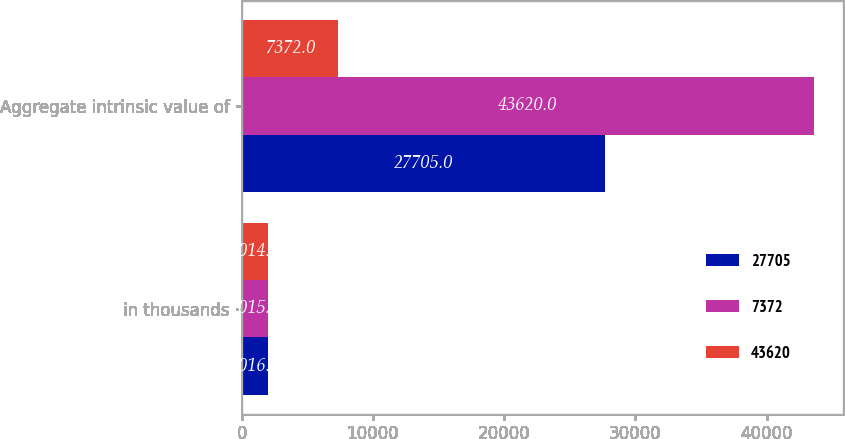Convert chart. <chart><loc_0><loc_0><loc_500><loc_500><stacked_bar_chart><ecel><fcel>in thousands<fcel>Aggregate intrinsic value of<nl><fcel>27705<fcel>2016<fcel>27705<nl><fcel>7372<fcel>2015<fcel>43620<nl><fcel>43620<fcel>2014<fcel>7372<nl></chart> 